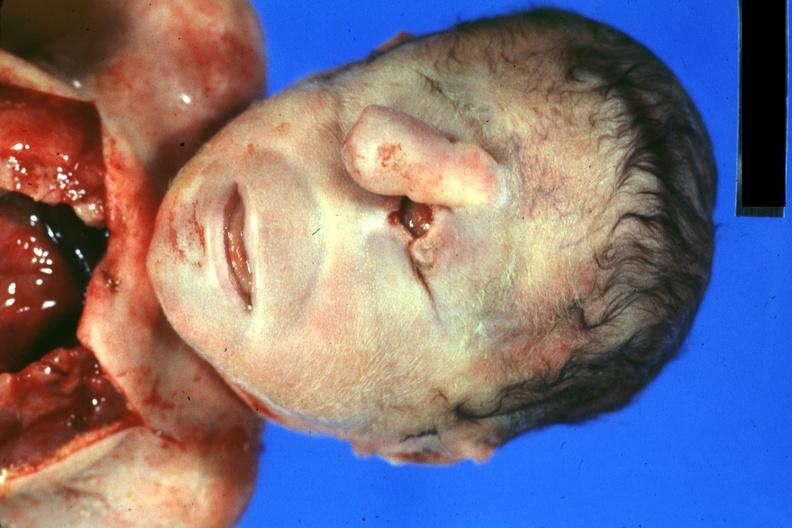s liver with tuberculoid granuloma in glissons present?
Answer the question using a single word or phrase. No 